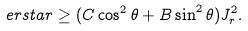<formula> <loc_0><loc_0><loc_500><loc_500>\ e r s t a r \geq ( C \cos ^ { 2 } \theta + B \sin ^ { 2 } \theta ) J _ { r } ^ { 2 } .</formula> 